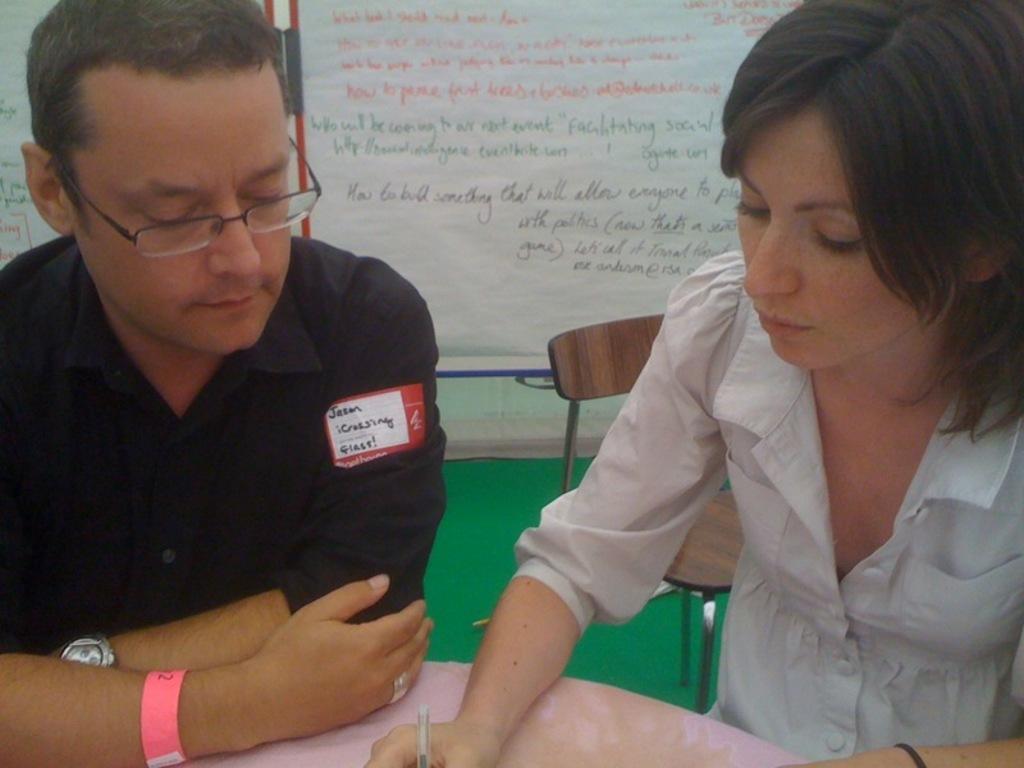Describe this image in one or two sentences. On the background we can see white boards and something written on it. This is a carpet in green color on the floor. Here we can see a women and a man sitting on chairs in front of a table. She is holding a pen in her hand. This man wore spectacles, watch and a wristband in pink colour. 